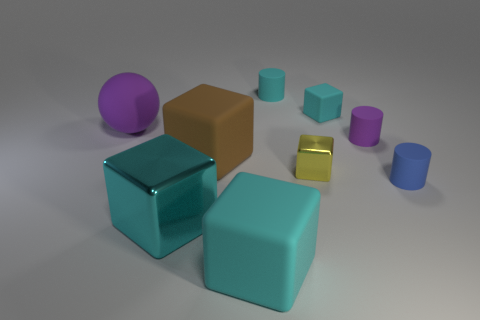How many cyan blocks must be subtracted to get 1 cyan blocks? 2 Subtract all yellow cylinders. How many cyan blocks are left? 3 Subtract all yellow blocks. How many blocks are left? 4 Subtract all yellow shiny blocks. How many blocks are left? 4 Subtract all red cubes. Subtract all brown cylinders. How many cubes are left? 5 Add 1 large blue rubber objects. How many objects exist? 10 Subtract all spheres. How many objects are left? 8 Add 3 purple metal cubes. How many purple metal cubes exist? 3 Subtract 0 green balls. How many objects are left? 9 Subtract all rubber things. Subtract all big matte cubes. How many objects are left? 0 